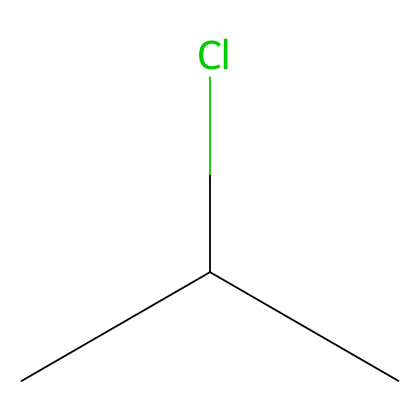What is the molecular formula of this chemical? By interpreting the SMILES notation, we can identify that there are two carbon atoms (C) and one chlorine atom (Cl) present. This gives a molecular formula of C2H3Cl.
Answer: C2H3Cl How many carbon atoms are present in the structure? By analyzing the SMILES representation, we can see that there are two carbon atoms (CC) in the structure.
Answer: 2 What type of bonding is present between the carbon atoms? The SMILES notation indicates that there is a single bond between the two carbon atoms (the absence of double or triple bond symbols confirms this).
Answer: single bond What functional group is represented by the chlorine substitution? The presence of chlorine (Cl) attached to one of the carbon atoms denotes the presence of a haloalkane functional group.
Answer: haloalkane Does this chemical contain any double or triple bonds? The SMILES does not indicate any double or triple bond symbols, confirming that all bonding between atoms is single.
Answer: no What characteristic makes this chemical suitable for use in plastics? The carbon-chlorine bond and the structure are integral in creating strong polymer chains, which is essential for the plasticity of PVC.
Answer: polymer chains 